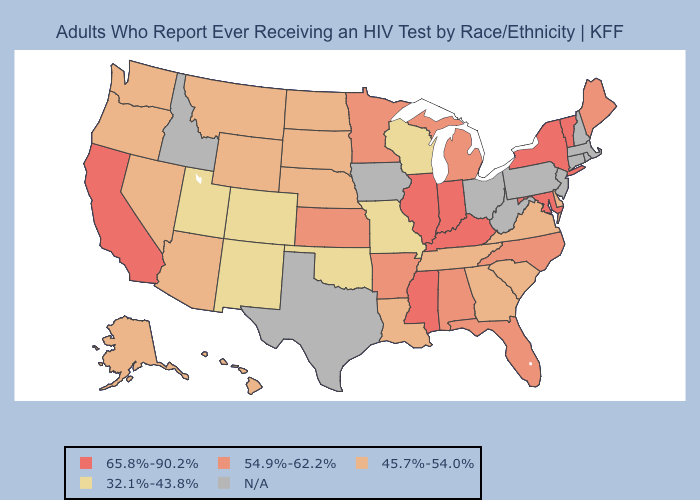What is the highest value in states that border Florida?
Write a very short answer. 54.9%-62.2%. Among the states that border Mississippi , does Louisiana have the lowest value?
Answer briefly. Yes. What is the value of Minnesota?
Concise answer only. 54.9%-62.2%. Name the states that have a value in the range 45.7%-54.0%?
Keep it brief. Alaska, Arizona, Delaware, Georgia, Hawaii, Louisiana, Montana, Nebraska, Nevada, North Dakota, Oregon, South Carolina, South Dakota, Tennessee, Virginia, Washington, Wyoming. Name the states that have a value in the range 32.1%-43.8%?
Give a very brief answer. Colorado, Missouri, New Mexico, Oklahoma, Utah, Wisconsin. Name the states that have a value in the range 54.9%-62.2%?
Quick response, please. Alabama, Arkansas, Florida, Kansas, Maine, Michigan, Minnesota, North Carolina. Name the states that have a value in the range 32.1%-43.8%?
Answer briefly. Colorado, Missouri, New Mexico, Oklahoma, Utah, Wisconsin. What is the highest value in the MidWest ?
Keep it brief. 65.8%-90.2%. Name the states that have a value in the range 54.9%-62.2%?
Short answer required. Alabama, Arkansas, Florida, Kansas, Maine, Michigan, Minnesota, North Carolina. Among the states that border Louisiana , which have the highest value?
Answer briefly. Mississippi. What is the value of Pennsylvania?
Keep it brief. N/A. What is the value of Oklahoma?
Short answer required. 32.1%-43.8%. Does Indiana have the highest value in the USA?
Concise answer only. Yes. Name the states that have a value in the range 54.9%-62.2%?
Keep it brief. Alabama, Arkansas, Florida, Kansas, Maine, Michigan, Minnesota, North Carolina. 